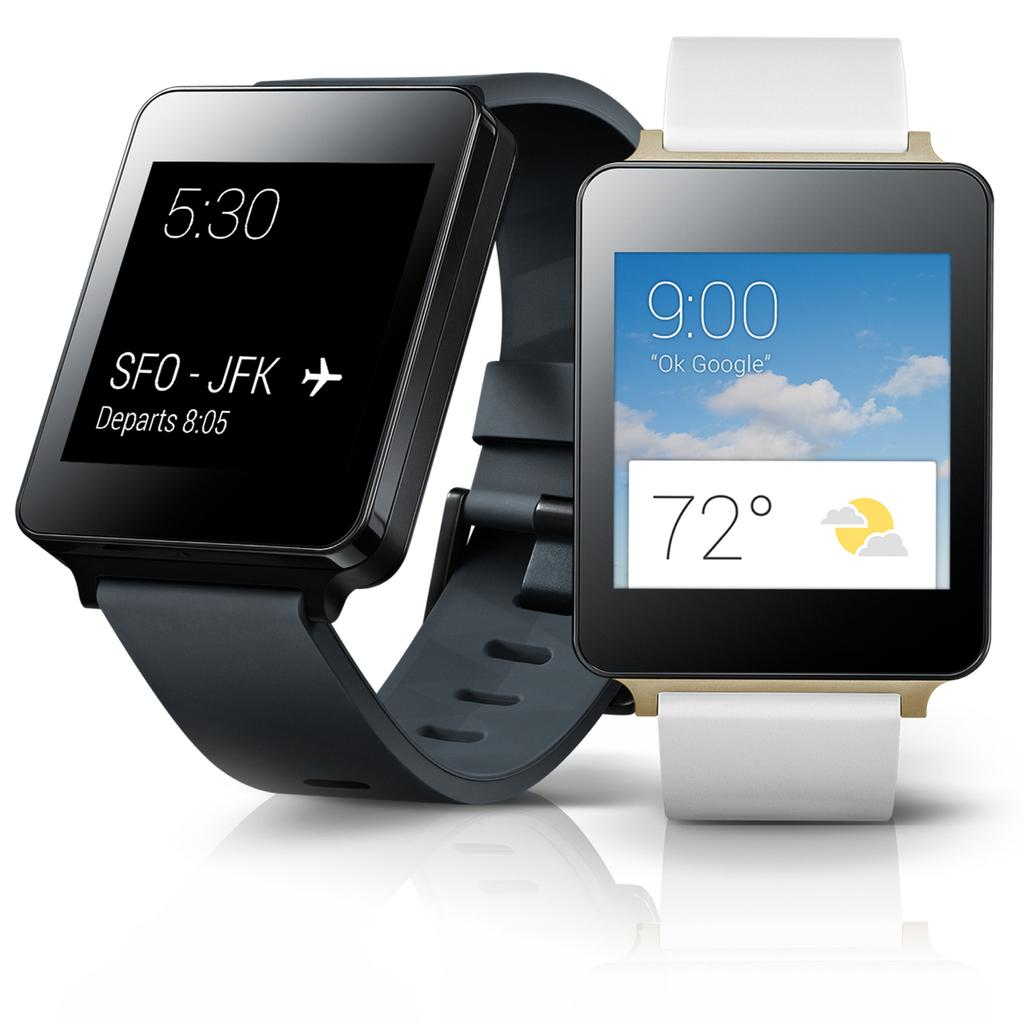<image>
Describe the image concisely. Two smart watches in black and in whit show the temperature is seventy two degrees on the right one. 